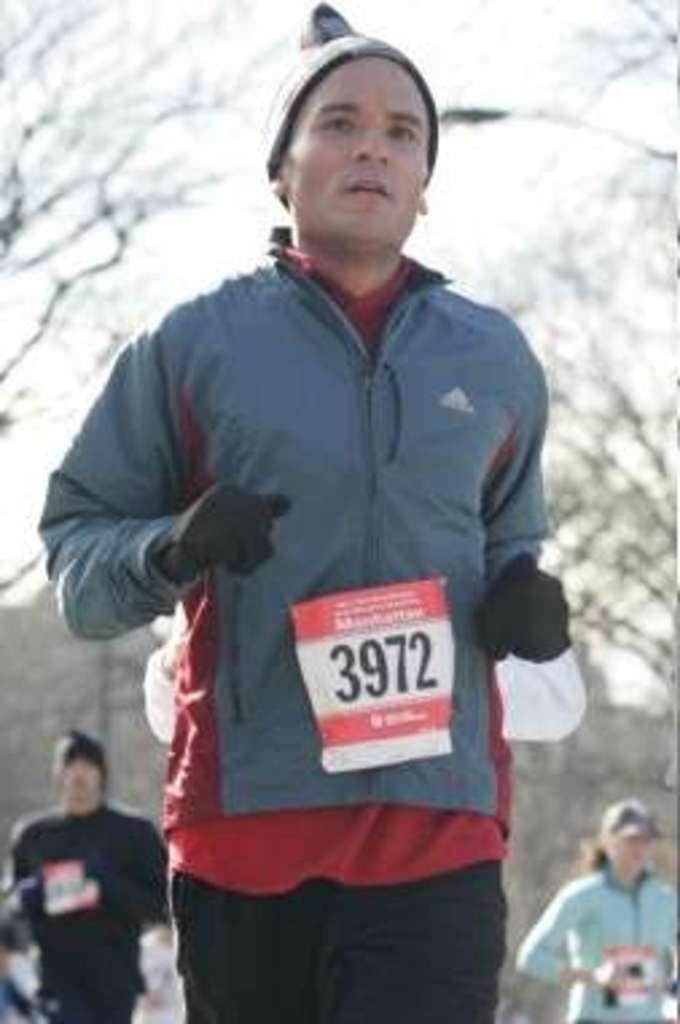How many people are present in the image? There are three persons standing in the image. What can be seen in the background of the image? There are trees and the sky visible in the background of the image. What type of cap is the coach wearing in the image? There is no coach or cap present in the image; it features three persons standing. How many planes can be seen flying in the image? There are no planes visible in the image. 